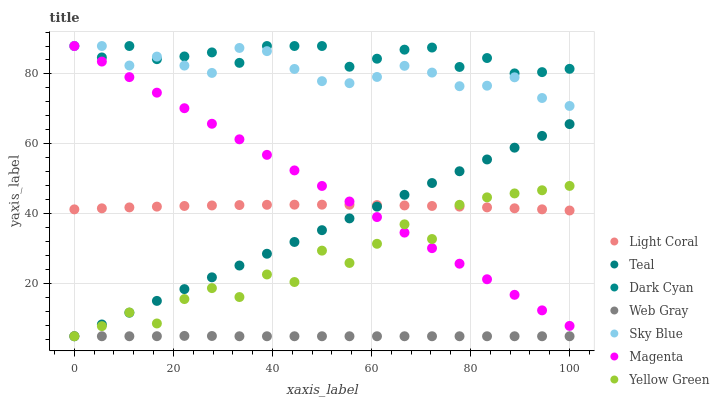Does Web Gray have the minimum area under the curve?
Answer yes or no. Yes. Does Dark Cyan have the maximum area under the curve?
Answer yes or no. Yes. Does Yellow Green have the minimum area under the curve?
Answer yes or no. No. Does Yellow Green have the maximum area under the curve?
Answer yes or no. No. Is Teal the smoothest?
Answer yes or no. Yes. Is Yellow Green the roughest?
Answer yes or no. Yes. Is Light Coral the smoothest?
Answer yes or no. No. Is Light Coral the roughest?
Answer yes or no. No. Does Web Gray have the lowest value?
Answer yes or no. Yes. Does Light Coral have the lowest value?
Answer yes or no. No. Does Magenta have the highest value?
Answer yes or no. Yes. Does Yellow Green have the highest value?
Answer yes or no. No. Is Web Gray less than Sky Blue?
Answer yes or no. Yes. Is Dark Cyan greater than Teal?
Answer yes or no. Yes. Does Teal intersect Magenta?
Answer yes or no. Yes. Is Teal less than Magenta?
Answer yes or no. No. Is Teal greater than Magenta?
Answer yes or no. No. Does Web Gray intersect Sky Blue?
Answer yes or no. No. 